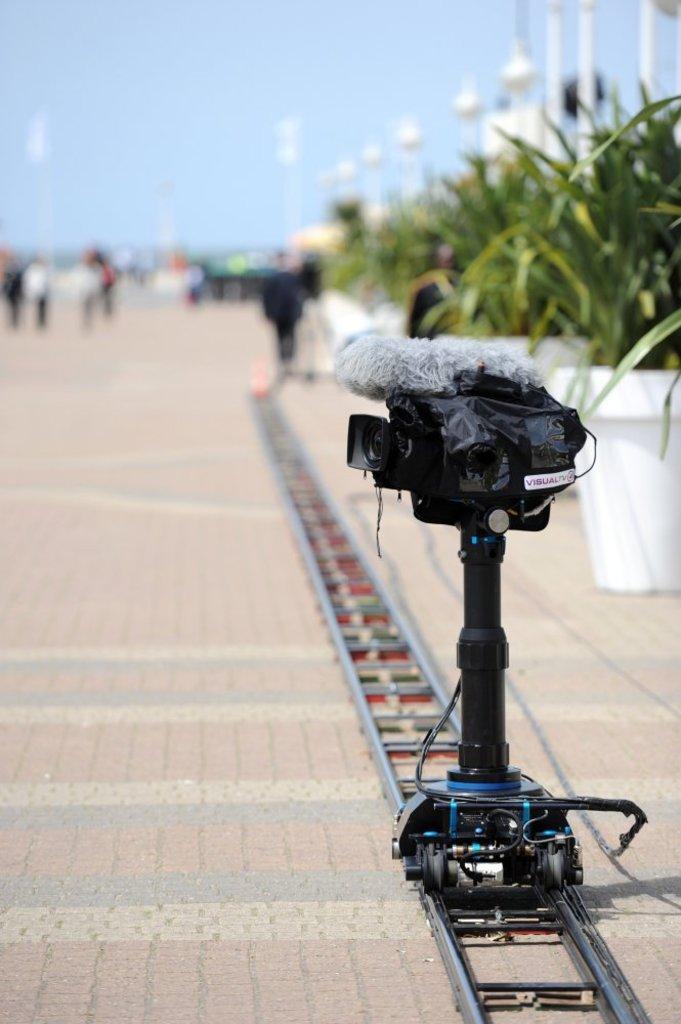In one or two sentences, can you explain what this image depicts? In this image there is a camera rolling on the tracks which is on pavement beside that there are people walking and some plant pots. 